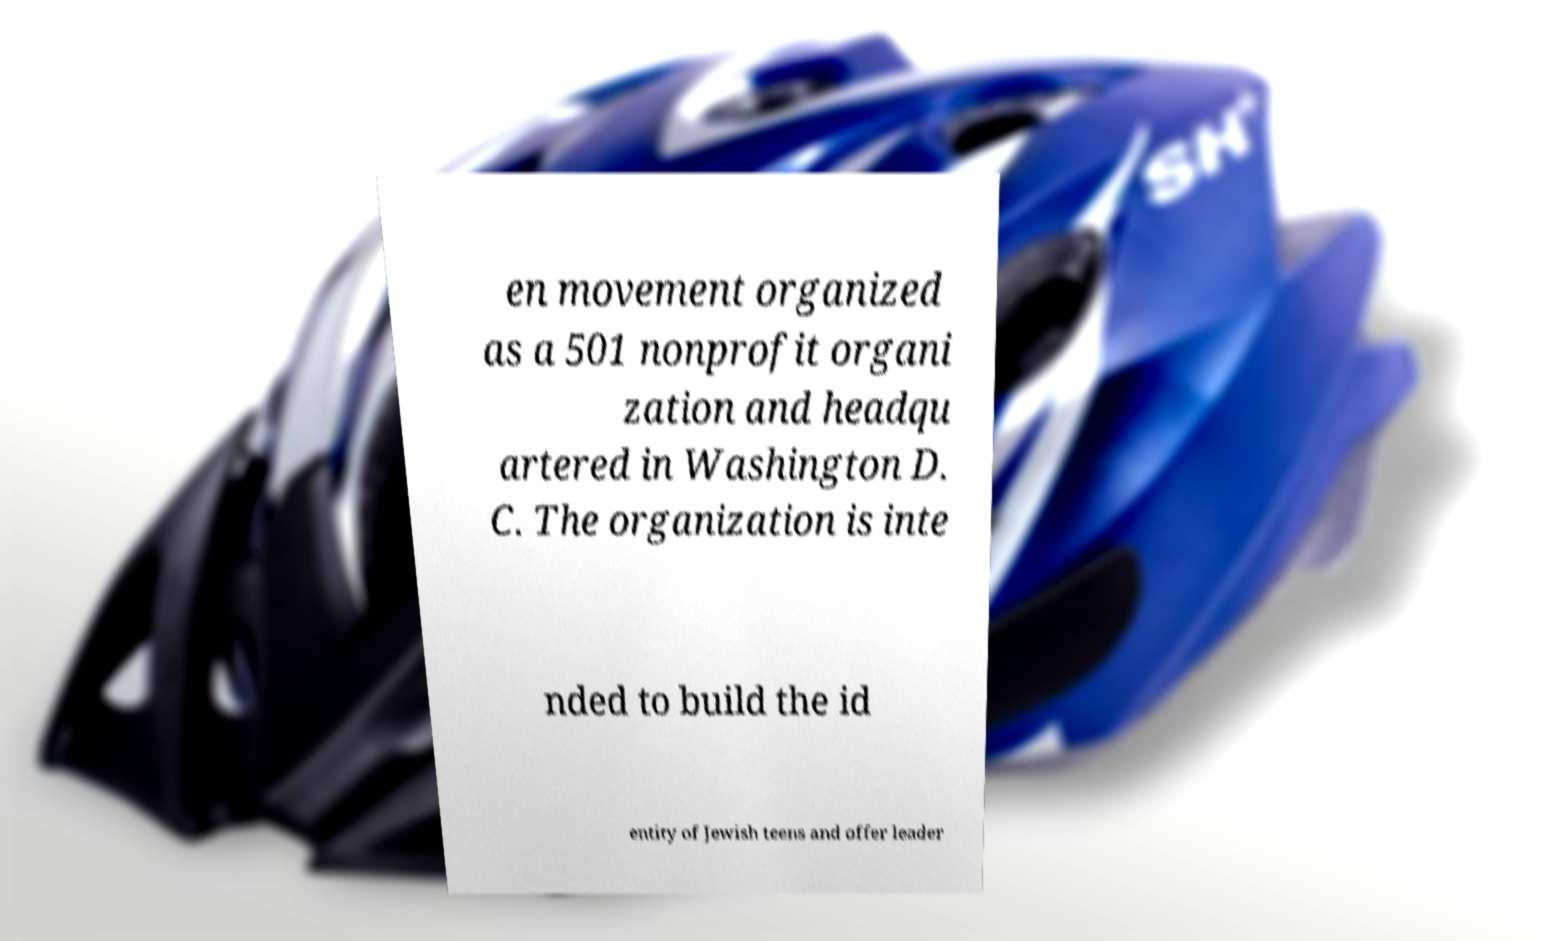Can you accurately transcribe the text from the provided image for me? en movement organized as a 501 nonprofit organi zation and headqu artered in Washington D. C. The organization is inte nded to build the id entity of Jewish teens and offer leader 